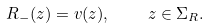<formula> <loc_0><loc_0><loc_500><loc_500>R _ { - } ( z ) = v ( z ) , \quad z \in \Sigma _ { R } .</formula> 